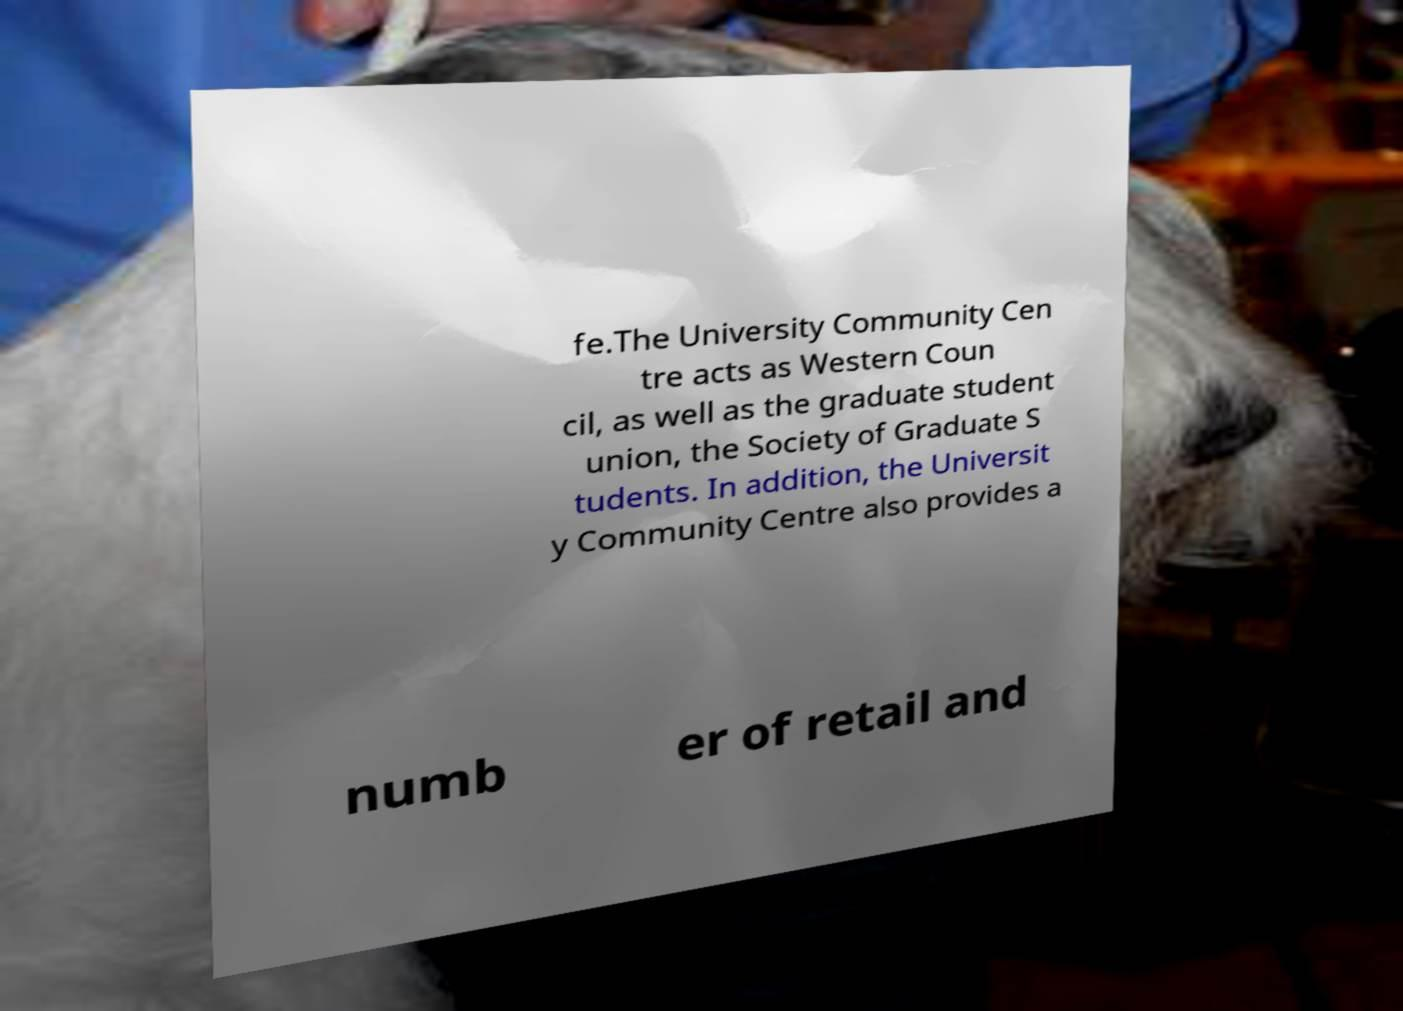I need the written content from this picture converted into text. Can you do that? fe.The University Community Cen tre acts as Western Coun cil, as well as the graduate student union, the Society of Graduate S tudents. In addition, the Universit y Community Centre also provides a numb er of retail and 